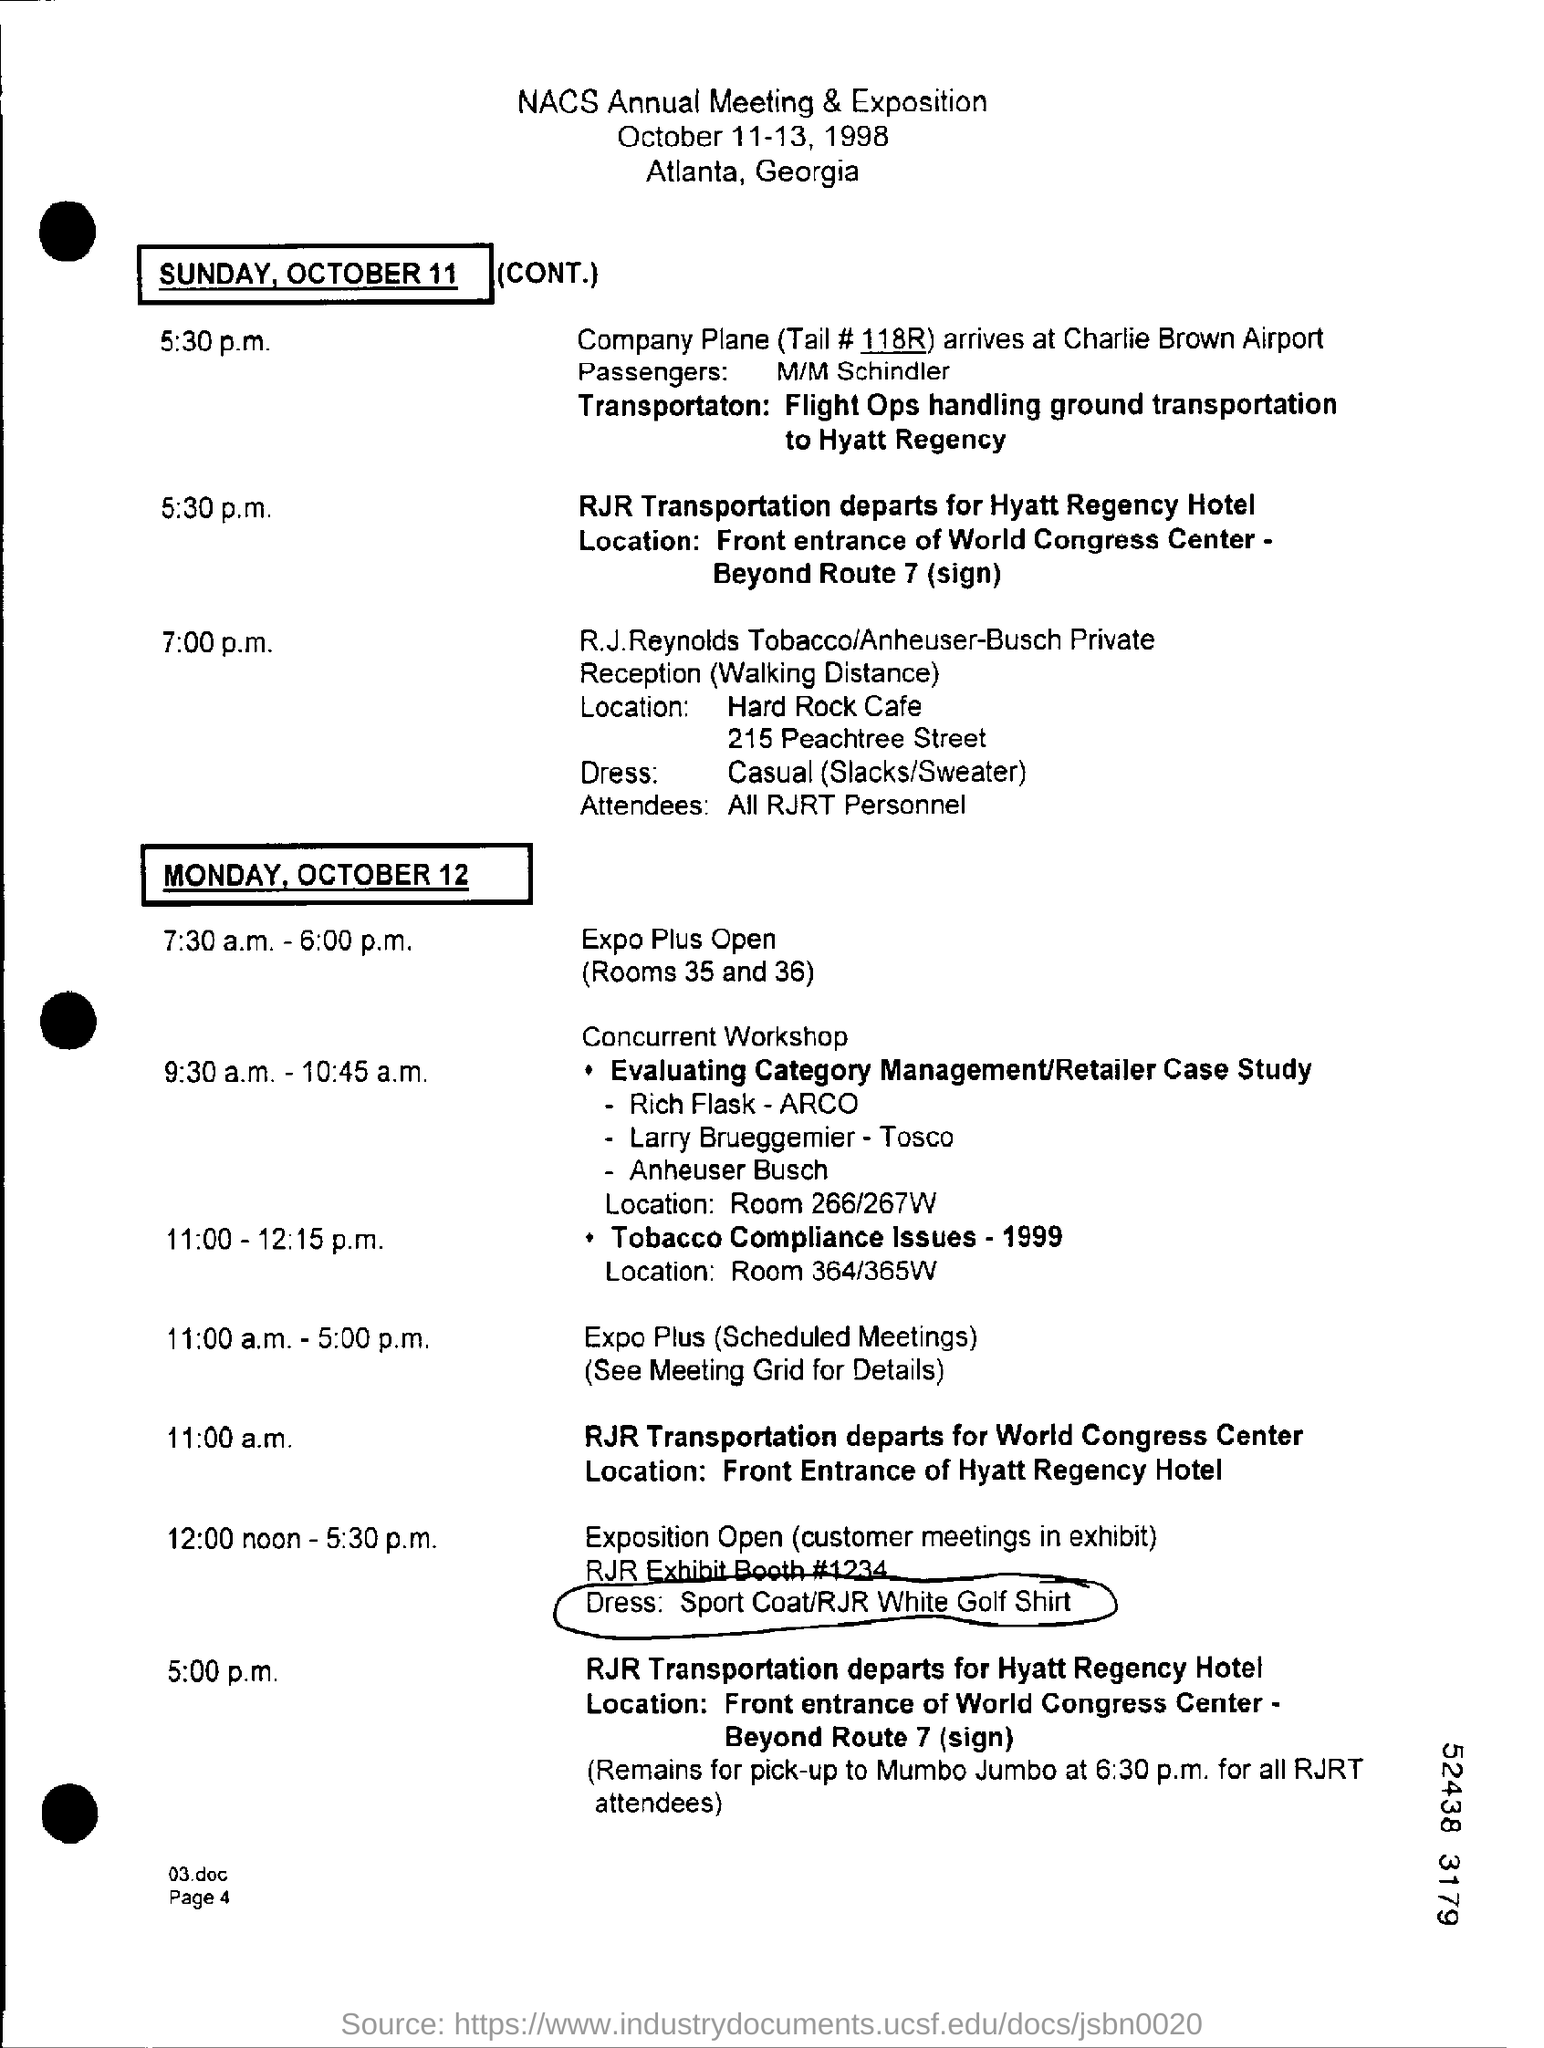What is the tail #?
Provide a short and direct response. 118R. When is the date nacs annual meeting & exposition on ?
Your answer should be compact. October 11-13, 1998. Where is the nacs annual meeting & exposition at ?
Provide a succinct answer. Atlanta, georgia. 